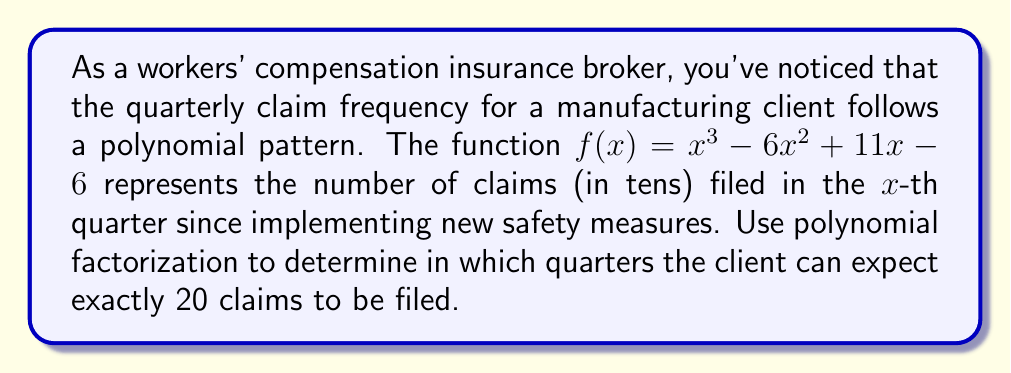Show me your answer to this math problem. Let's approach this step-by-step:

1) We need to find the values of $x$ where $f(x) = 2$, as 20 claims is represented by 2 in the function (since it's in tens).

2) Set up the equation:
   $$x^3 - 6x^2 + 11x - 6 = 2$$

3) Subtract 2 from both sides:
   $$x^3 - 6x^2 + 11x - 8 = 0$$

4) Now, we need to factor this polynomial. Let's try to guess one factor first. We can see that $x = 1$ is a solution (1³ - 6·1² + 11·1 - 8 = 0).

5) Using polynomial long division or the factor theorem, we can divide by $(x - 1)$:
   $$x^3 - 6x^2 + 11x - 8 = (x - 1)(x^2 - 5x + 8)$$

6) The quadratic factor $x^2 - 5x + 8$ can be factored further:
   $$x^2 - 5x + 8 = (x - 2)(x - 3)$$

7) Therefore, the complete factorization is:
   $$x^3 - 6x^2 + 11x - 8 = (x - 1)(x - 2)(x - 3)$$

8) The solutions to this equation are $x = 1$, $x = 2$, and $x = 3$.

9) These $x$ values represent the quarters where exactly 20 claims will be filed.
Answer: 1st, 2nd, and 3rd quarters 